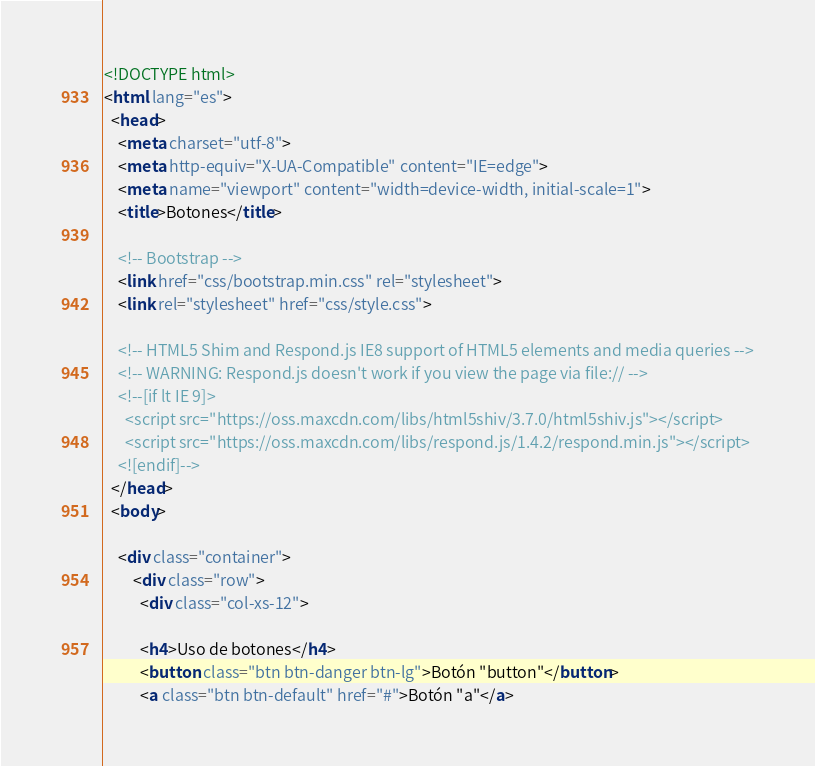Convert code to text. <code><loc_0><loc_0><loc_500><loc_500><_HTML_><!DOCTYPE html>
<html lang="es">
  <head>
    <meta charset="utf-8">
    <meta http-equiv="X-UA-Compatible" content="IE=edge">
    <meta name="viewport" content="width=device-width, initial-scale=1">
    <title>Botones</title>

    <!-- Bootstrap -->
    <link href="css/bootstrap.min.css" rel="stylesheet">
    <link rel="stylesheet" href="css/style.css">

    <!-- HTML5 Shim and Respond.js IE8 support of HTML5 elements and media queries -->
    <!-- WARNING: Respond.js doesn't work if you view the page via file:// -->
    <!--[if lt IE 9]>
      <script src="https://oss.maxcdn.com/libs/html5shiv/3.7.0/html5shiv.js"></script>
      <script src="https://oss.maxcdn.com/libs/respond.js/1.4.2/respond.min.js"></script>
    <![endif]-->
  </head>
  <body>
        
    <div class="container">      
        <div class="row">
          <div class="col-xs-12">          
           
          <h4>Uso de botones</h4>
          <button class="btn btn-danger btn-lg">Botón "button"</button>
          <a class="btn btn-default" href="#">Botón "a"</a></code> 